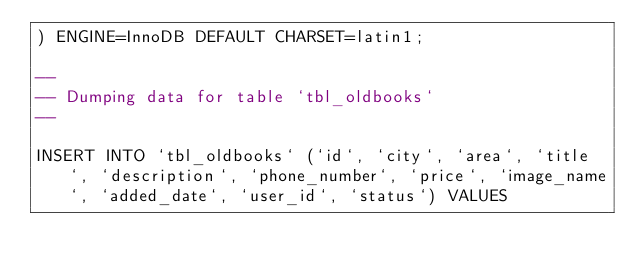<code> <loc_0><loc_0><loc_500><loc_500><_SQL_>) ENGINE=InnoDB DEFAULT CHARSET=latin1;

--
-- Dumping data for table `tbl_oldbooks`
--

INSERT INTO `tbl_oldbooks` (`id`, `city`, `area`, `title`, `description`, `phone_number`, `price`, `image_name`, `added_date`, `user_id`, `status`) VALUES</code> 